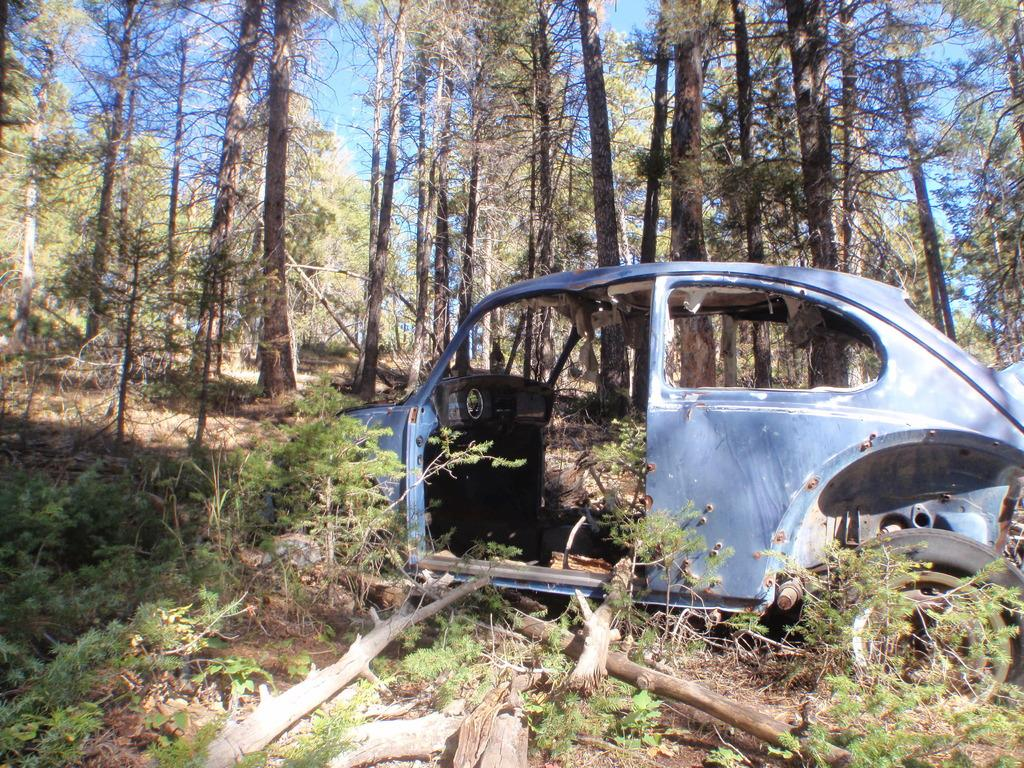What type of vehicle is in the image? There is an old car in the image. What type of vegetation is present in the image? There are green trees in the image. What color is the sky in the image? The sky is blue in the image. What type of jeans is the car wearing in the image? Cars do not wear jeans, as they are inanimate objects. 